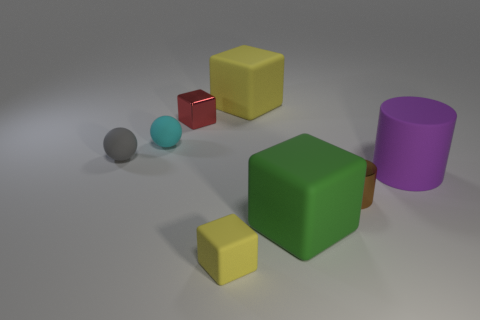Subtract all yellow cubes. How many were subtracted if there are1yellow cubes left? 1 Add 1 large cyan rubber cylinders. How many objects exist? 9 Subtract all balls. How many objects are left? 6 Add 8 tiny rubber cubes. How many tiny rubber cubes exist? 9 Subtract 0 brown blocks. How many objects are left? 8 Subtract all yellow matte objects. Subtract all tiny red shiny cubes. How many objects are left? 5 Add 3 tiny red objects. How many tiny red objects are left? 4 